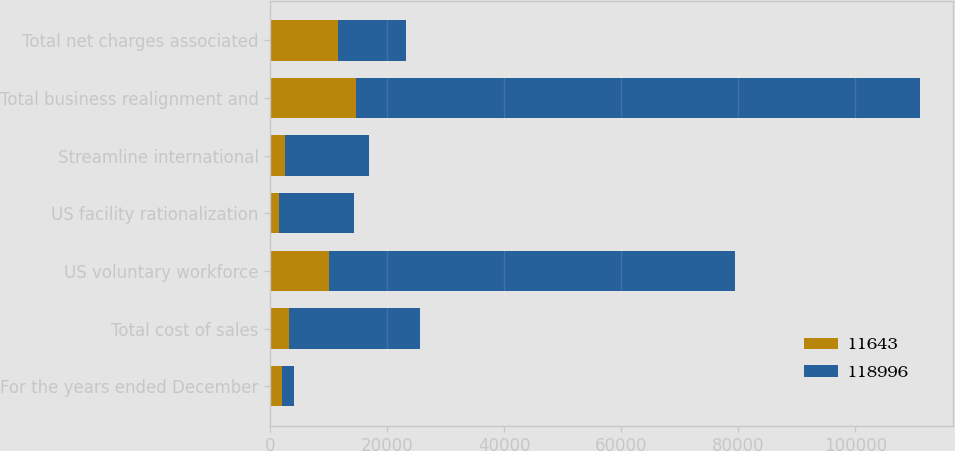Convert chart to OTSL. <chart><loc_0><loc_0><loc_500><loc_500><stacked_bar_chart><ecel><fcel>For the years ended December<fcel>Total cost of sales<fcel>US voluntary workforce<fcel>US facility rationalization<fcel>Streamline international<fcel>Total business realignment and<fcel>Total net charges associated<nl><fcel>11643<fcel>2006<fcel>3199<fcel>9972<fcel>1567<fcel>2524<fcel>14576<fcel>11643<nl><fcel>118996<fcel>2005<fcel>22459<fcel>69472<fcel>12771<fcel>14294<fcel>96537<fcel>11643<nl></chart> 